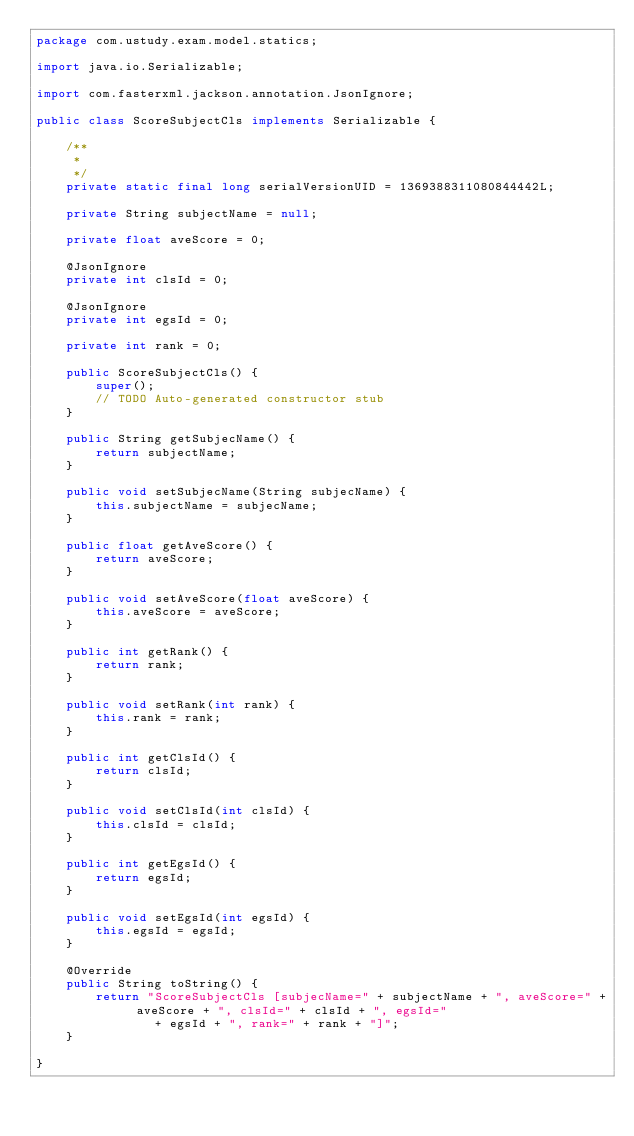Convert code to text. <code><loc_0><loc_0><loc_500><loc_500><_Java_>package com.ustudy.exam.model.statics;

import java.io.Serializable;

import com.fasterxml.jackson.annotation.JsonIgnore;

public class ScoreSubjectCls implements Serializable {

	/**
	 * 
	 */
	private static final long serialVersionUID = 1369388311080844442L;

	private String subjectName = null;
	
	private float aveScore = 0;
	
	@JsonIgnore
	private int clsId = 0;
	
	@JsonIgnore
	private int egsId = 0;
	
	private int rank = 0;
	
	public ScoreSubjectCls() {
		super();
		// TODO Auto-generated constructor stub
	}

	public String getSubjecName() {
		return subjectName;
	}

	public void setSubjecName(String subjecName) {
		this.subjectName = subjecName;
	}

	public float getAveScore() {
		return aveScore;
	}

	public void setAveScore(float aveScore) {
		this.aveScore = aveScore;
	}

	public int getRank() {
		return rank;
	}

	public void setRank(int rank) {
		this.rank = rank;
	}

	public int getClsId() {
		return clsId;
	}

	public void setClsId(int clsId) {
		this.clsId = clsId;
	}

	public int getEgsId() {
		return egsId;
	}

	public void setEgsId(int egsId) {
		this.egsId = egsId;
	}

	@Override
	public String toString() {
		return "ScoreSubjectCls [subjecName=" + subjectName + ", aveScore=" + aveScore + ", clsId=" + clsId + ", egsId="
				+ egsId + ", rank=" + rank + "]";
	}
	
}
</code> 